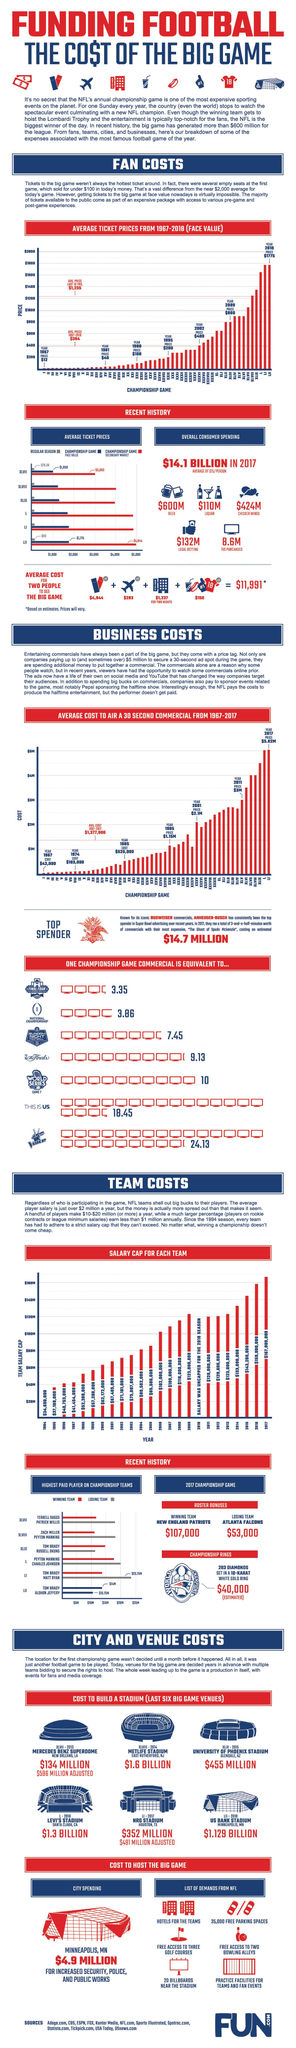Specify some key components in this picture. The NFL Championship game XLIX was conducted in 2015 at the UNIVERSITY OF PHOENIX STADIUM. The NFL Championship game XLVIII was held at MetLife Stadium in 2014. The average cost for flight tickets for two people to attend an NFL Championship game in 2017 was $283. The average face value of Championship game XLVII tickets in 2017 was $1,050. In 2016, the cost of building Levi's Stadium for the NFL Championship game was a staggering $1.3 BILLION. 